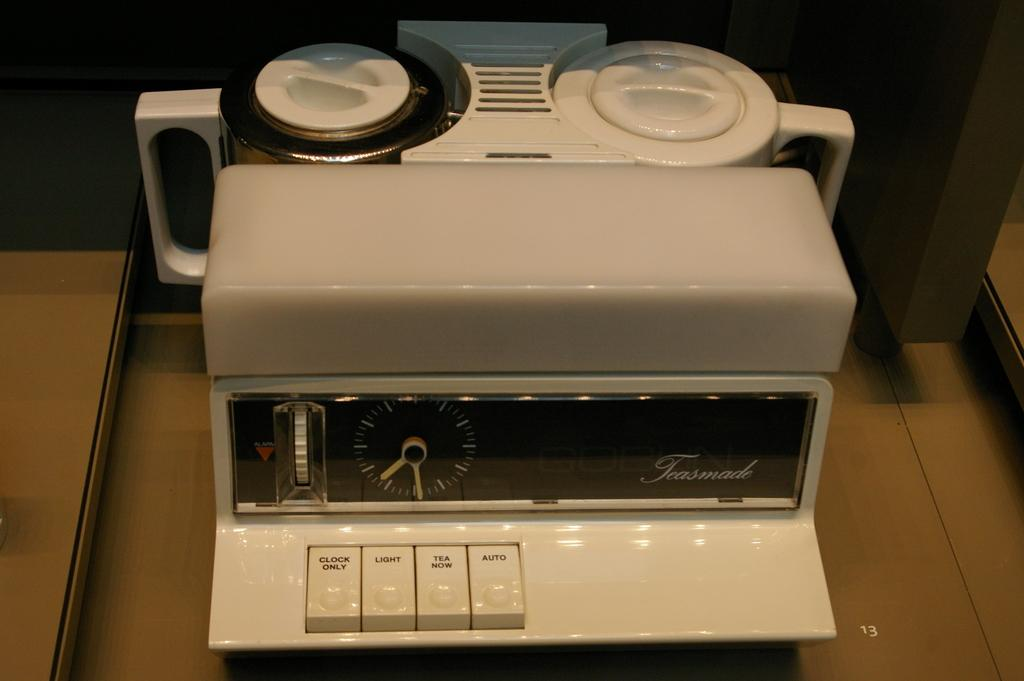Provide a one-sentence caption for the provided image. an old fashioned percolator with clock from Teasmade. 